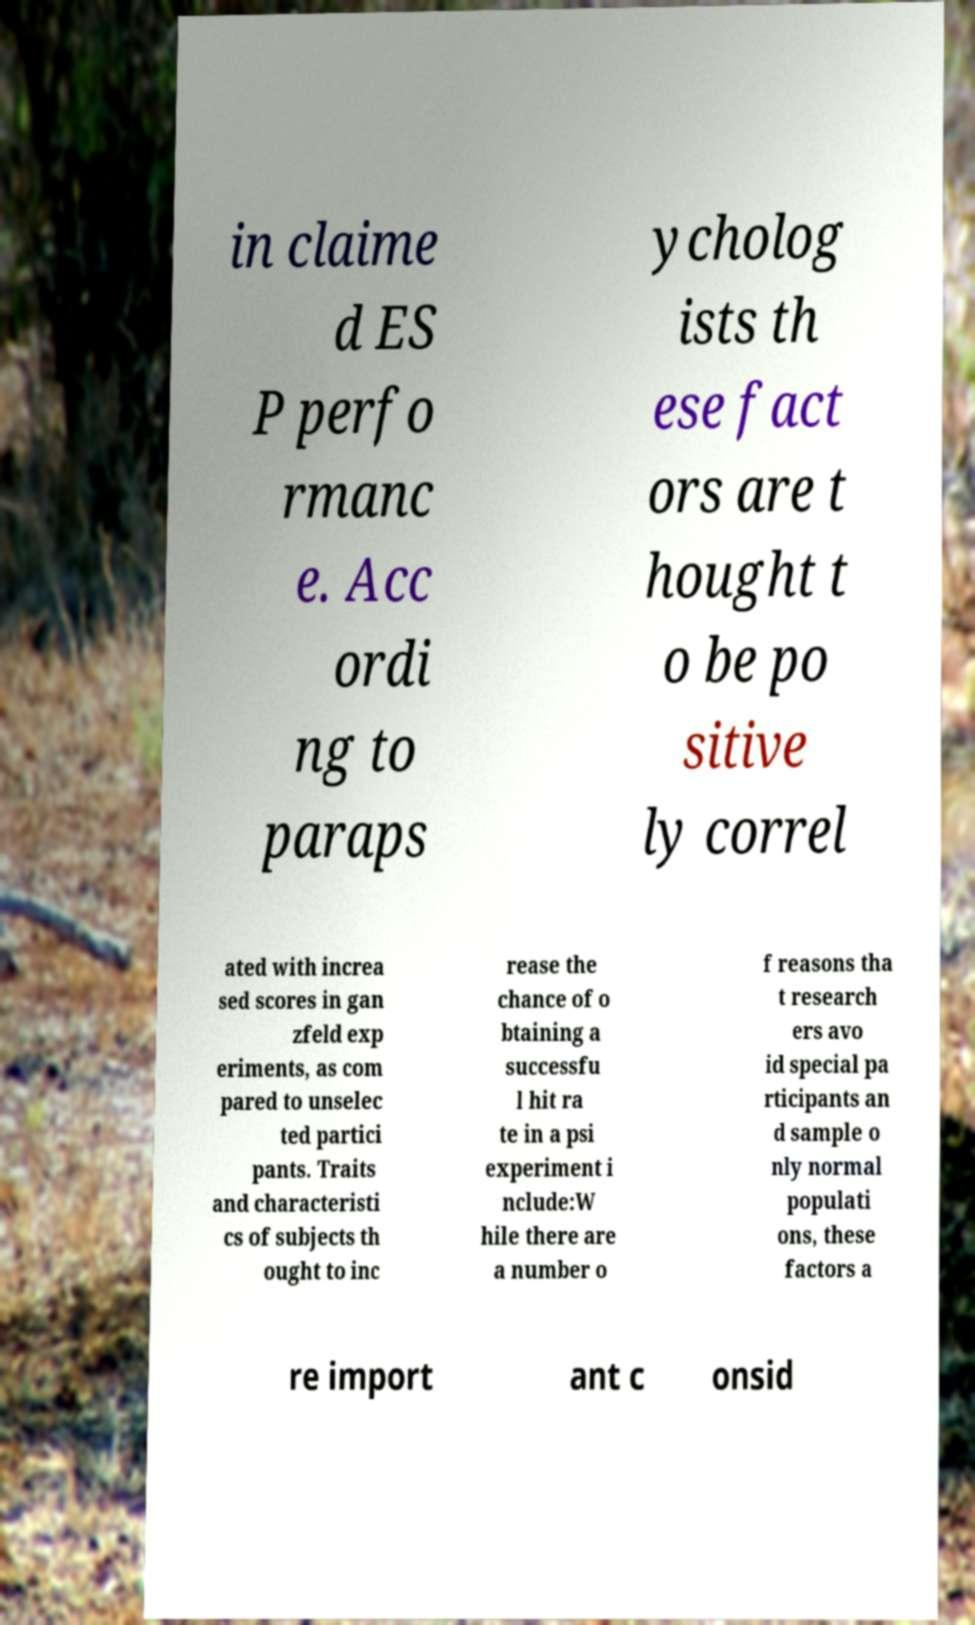Could you extract and type out the text from this image? in claime d ES P perfo rmanc e. Acc ordi ng to paraps ycholog ists th ese fact ors are t hought t o be po sitive ly correl ated with increa sed scores in gan zfeld exp eriments, as com pared to unselec ted partici pants. Traits and characteristi cs of subjects th ought to inc rease the chance of o btaining a successfu l hit ra te in a psi experiment i nclude:W hile there are a number o f reasons tha t research ers avo id special pa rticipants an d sample o nly normal populati ons, these factors a re import ant c onsid 